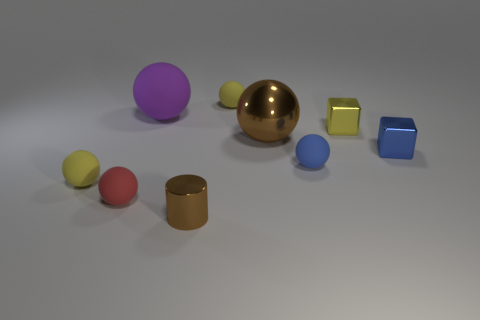How many small yellow spheres are the same material as the small blue sphere?
Give a very brief answer. 2. There is another block that is the same material as the blue block; what is its color?
Give a very brief answer. Yellow. The tiny blue metallic thing has what shape?
Your answer should be compact. Cube. There is a yellow ball on the right side of the large purple sphere; what is it made of?
Offer a terse response. Rubber. Is there another large matte thing of the same color as the big matte object?
Give a very brief answer. No. What is the shape of the brown metallic object that is the same size as the purple rubber sphere?
Offer a very short reply. Sphere. What color is the matte object behind the purple sphere?
Make the answer very short. Yellow. There is a tiny yellow rubber sphere behind the big rubber thing; is there a small metal block behind it?
Give a very brief answer. No. How many objects are either balls behind the small red thing or small yellow shiny things?
Your answer should be compact. 6. Are there any other things that have the same size as the purple rubber ball?
Make the answer very short. Yes. 